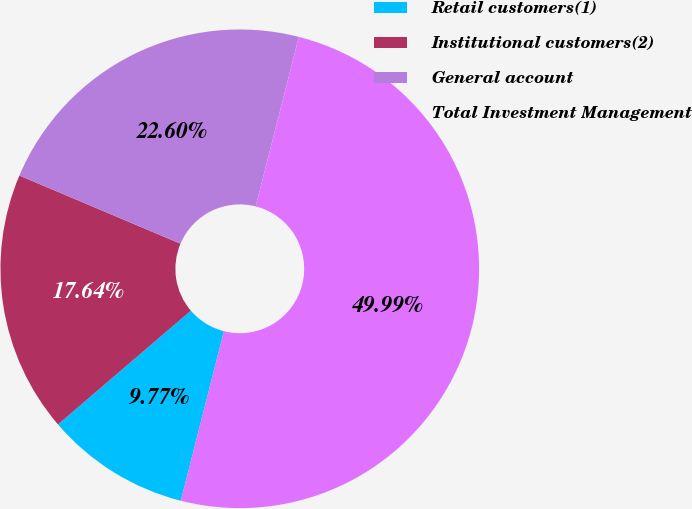Convert chart to OTSL. <chart><loc_0><loc_0><loc_500><loc_500><pie_chart><fcel>Retail customers(1)<fcel>Institutional customers(2)<fcel>General account<fcel>Total Investment Management<nl><fcel>9.77%<fcel>17.64%<fcel>22.6%<fcel>50.0%<nl></chart> 